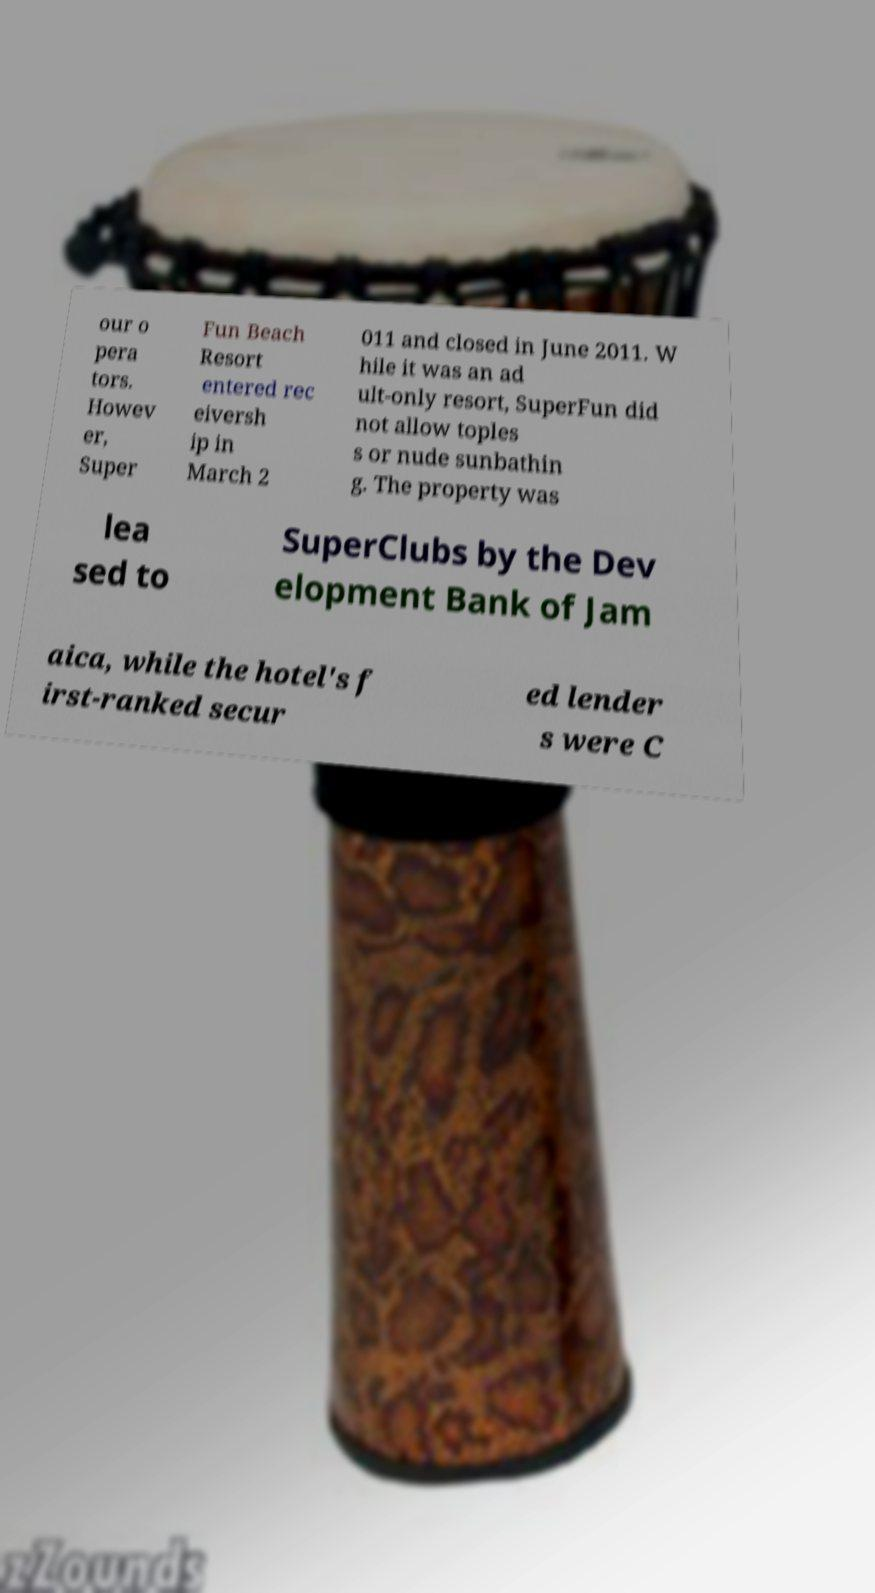Could you assist in decoding the text presented in this image and type it out clearly? our o pera tors. Howev er, Super Fun Beach Resort entered rec eiversh ip in March 2 011 and closed in June 2011. W hile it was an ad ult-only resort, SuperFun did not allow toples s or nude sunbathin g. The property was lea sed to SuperClubs by the Dev elopment Bank of Jam aica, while the hotel's f irst-ranked secur ed lender s were C 